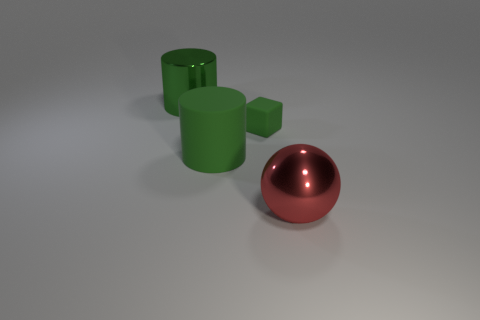Do the small thing and the large shiny thing behind the big red metal ball have the same color?
Provide a short and direct response. Yes. There is a block that is the same color as the big metallic cylinder; what is its size?
Provide a succinct answer. Small. Is the number of red shiny spheres that are to the right of the cube greater than the number of things that are to the left of the sphere?
Provide a succinct answer. No. What number of big green objects are behind the cylinder that is in front of the tiny matte object?
Provide a succinct answer. 1. There is a block that is the same color as the big rubber thing; what material is it?
Provide a short and direct response. Rubber. How many other things are the same color as the small object?
Provide a succinct answer. 2. What is the color of the metal thing to the right of the metallic object that is behind the big red ball?
Your answer should be compact. Red. Are there any large metallic cylinders of the same color as the large rubber cylinder?
Make the answer very short. Yes. How many metallic objects are either large green objects or red things?
Your response must be concise. 2. Are there any blocks that have the same material as the big red ball?
Make the answer very short. No. 